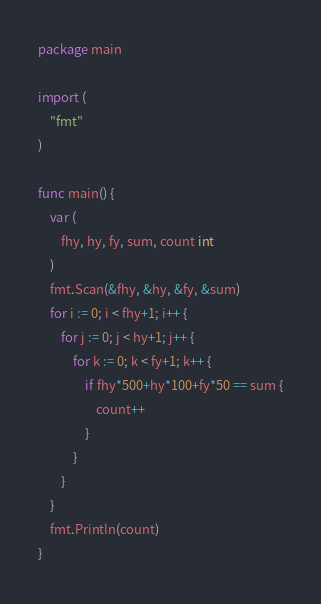Convert code to text. <code><loc_0><loc_0><loc_500><loc_500><_Go_>package main

import (
	"fmt"
)

func main() {
	var (
		fhy, hy, fy, sum, count int
	)
	fmt.Scan(&fhy, &hy, &fy, &sum)
	for i := 0; i < fhy+1; i++ {
		for j := 0; j < hy+1; j++ {
			for k := 0; k < fy+1; k++ {
				if fhy*500+hy*100+fy*50 == sum {
					count++
				}
			}
		}
	}
	fmt.Println(count)
}
</code> 